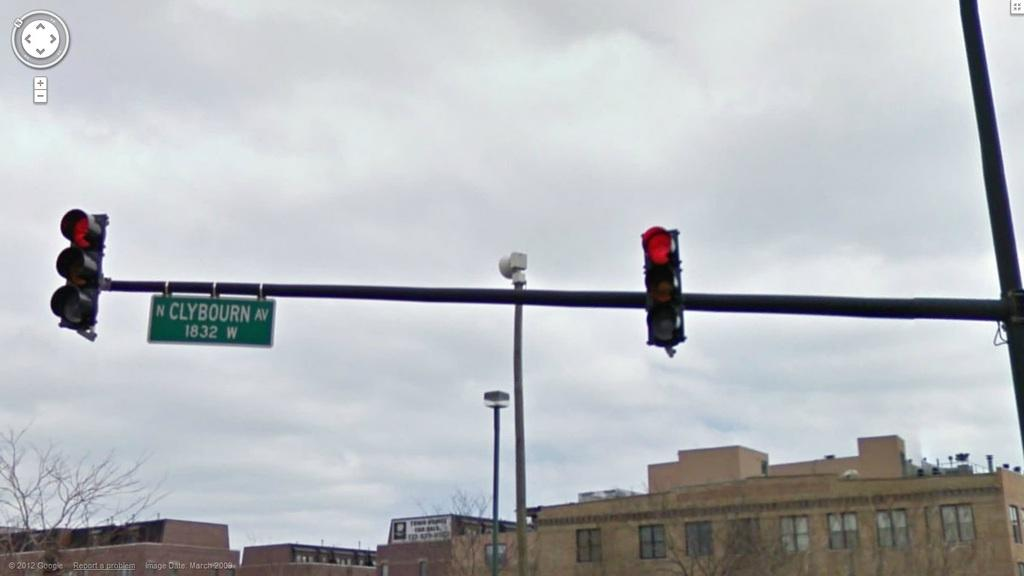<image>
Share a concise interpretation of the image provided. clybourn street which is above the street next to a light 